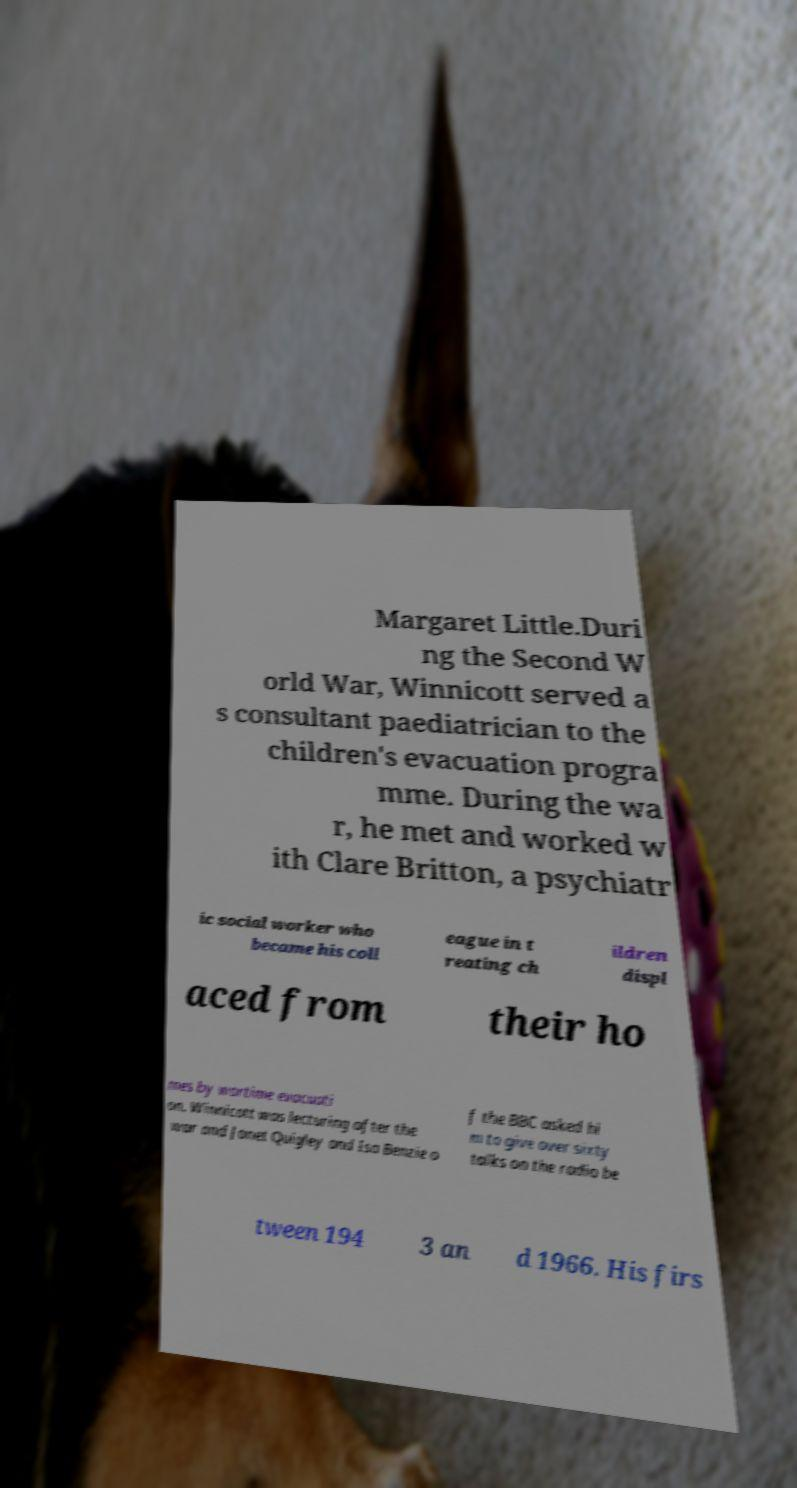For documentation purposes, I need the text within this image transcribed. Could you provide that? Margaret Little.Duri ng the Second W orld War, Winnicott served a s consultant paediatrician to the children's evacuation progra mme. During the wa r, he met and worked w ith Clare Britton, a psychiatr ic social worker who became his coll eague in t reating ch ildren displ aced from their ho mes by wartime evacuati on. Winnicott was lecturing after the war and Janet Quigley and Isa Benzie o f the BBC asked hi m to give over sixty talks on the radio be tween 194 3 an d 1966. His firs 